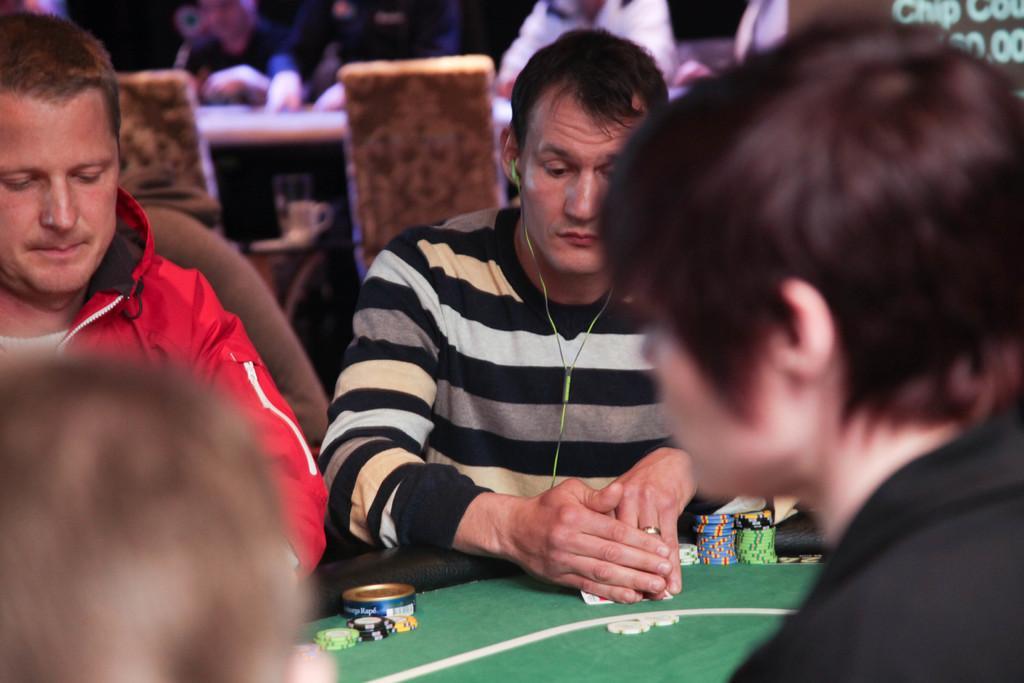Describe this image in one or two sentences. In this image, there is a table which is in green color, there are some people sitting on the chairs around the table. In the background there are some chairs which are in yellow color, there are some people sitting on the chairs. 